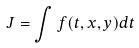Convert formula to latex. <formula><loc_0><loc_0><loc_500><loc_500>J = \int f ( t , x , y ) d t</formula> 